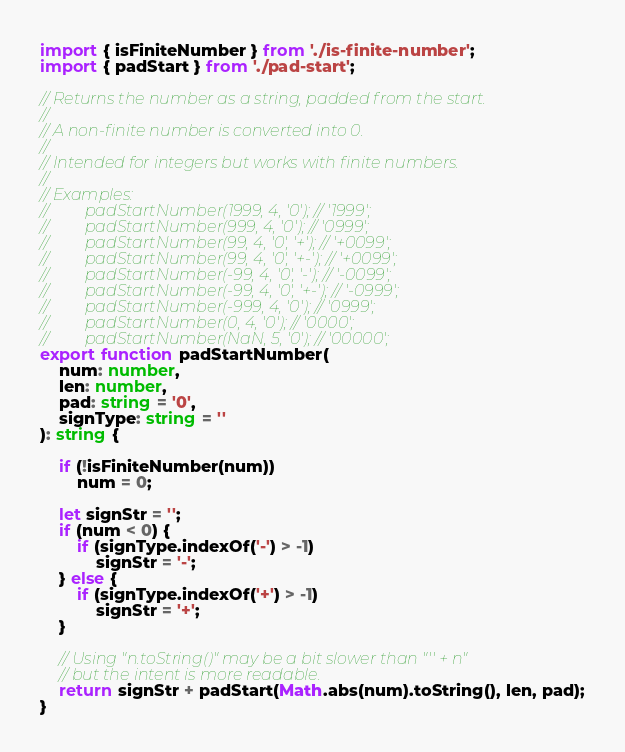Convert code to text. <code><loc_0><loc_0><loc_500><loc_500><_TypeScript_>import { isFiniteNumber } from './is-finite-number';
import { padStart } from './pad-start';

// Returns the number as a string, padded from the start.
//
// A non-finite number is converted into 0.
//
// Intended for integers but works with finite numbers.
//
// Examples:
//         padStartNumber(1999, 4, '0'); // '1999';
//         padStartNumber(999, 4, '0'); // '0999';
//         padStartNumber(99, 4, '0', '+'); // '+0099';
//         padStartNumber(99, 4, '0', '+-'); // '+0099';
//         padStartNumber(-99, 4, '0', '-'); // '-0099';
//         padStartNumber(-99, 4, '0', '+-'); // '-0999';
//         padStartNumber(-999, 4, '0'); // '0999';
//         padStartNumber(0, 4, '0'); // '0000';
//         padStartNumber(NaN, 5, '0'); // '00000';
export function padStartNumber(
	num: number,
	len: number,
	pad: string = '0',
	signType: string = ''
): string {

	if (!isFiniteNumber(num))
		num = 0;

	let signStr = '';
	if (num < 0) {
		if (signType.indexOf('-') > -1)
			signStr = '-';
	} else {
		if (signType.indexOf('+') > -1)
			signStr = '+';
	}

	// Using "n.toString()" may be a bit slower than "'' + n"
	// but the intent is more readable.
	return signStr + padStart(Math.abs(num).toString(), len, pad);
}
</code> 